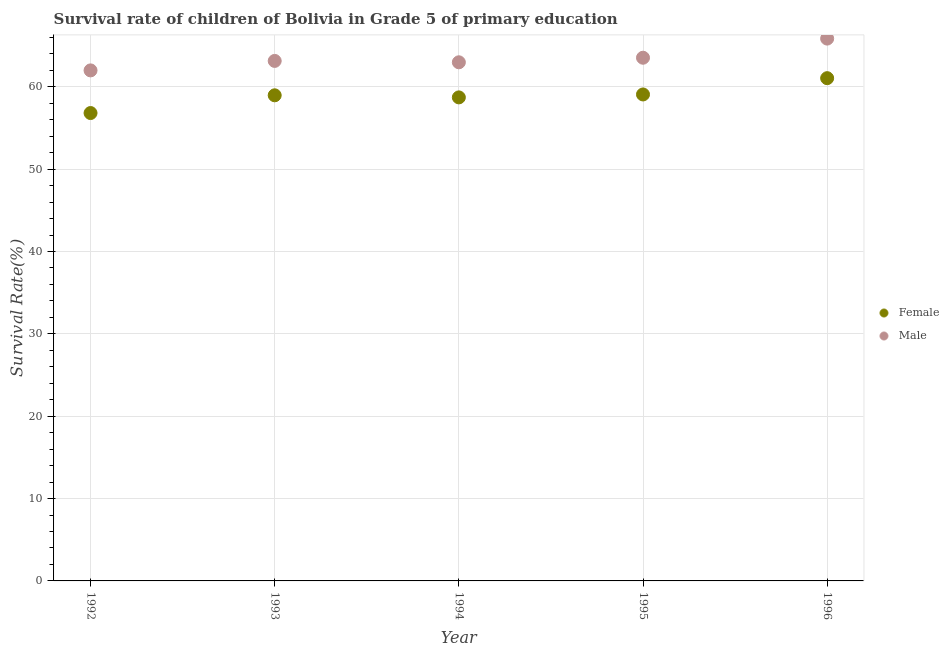Is the number of dotlines equal to the number of legend labels?
Your response must be concise. Yes. What is the survival rate of male students in primary education in 1994?
Offer a terse response. 62.98. Across all years, what is the maximum survival rate of male students in primary education?
Provide a succinct answer. 65.85. Across all years, what is the minimum survival rate of male students in primary education?
Your answer should be very brief. 61.99. In which year was the survival rate of female students in primary education minimum?
Provide a succinct answer. 1992. What is the total survival rate of female students in primary education in the graph?
Ensure brevity in your answer.  294.62. What is the difference between the survival rate of male students in primary education in 1992 and that in 1995?
Provide a short and direct response. -1.54. What is the difference between the survival rate of female students in primary education in 1994 and the survival rate of male students in primary education in 1993?
Your answer should be compact. -4.43. What is the average survival rate of female students in primary education per year?
Make the answer very short. 58.92. In the year 1994, what is the difference between the survival rate of male students in primary education and survival rate of female students in primary education?
Ensure brevity in your answer.  4.26. What is the ratio of the survival rate of female students in primary education in 1995 to that in 1996?
Make the answer very short. 0.97. Is the difference between the survival rate of male students in primary education in 1995 and 1996 greater than the difference between the survival rate of female students in primary education in 1995 and 1996?
Your response must be concise. No. What is the difference between the highest and the second highest survival rate of female students in primary education?
Provide a succinct answer. 1.98. What is the difference between the highest and the lowest survival rate of female students in primary education?
Offer a terse response. 4.23. In how many years, is the survival rate of male students in primary education greater than the average survival rate of male students in primary education taken over all years?
Ensure brevity in your answer.  2. Is the sum of the survival rate of female students in primary education in 1992 and 1993 greater than the maximum survival rate of male students in primary education across all years?
Keep it short and to the point. Yes. Does the survival rate of female students in primary education monotonically increase over the years?
Offer a terse response. No. Is the survival rate of male students in primary education strictly greater than the survival rate of female students in primary education over the years?
Provide a succinct answer. Yes. How many dotlines are there?
Make the answer very short. 2. How many years are there in the graph?
Your answer should be very brief. 5. What is the difference between two consecutive major ticks on the Y-axis?
Your answer should be very brief. 10. Does the graph contain any zero values?
Provide a short and direct response. No. Where does the legend appear in the graph?
Offer a very short reply. Center right. What is the title of the graph?
Give a very brief answer. Survival rate of children of Bolivia in Grade 5 of primary education. What is the label or title of the Y-axis?
Your response must be concise. Survival Rate(%). What is the Survival Rate(%) in Female in 1992?
Give a very brief answer. 56.81. What is the Survival Rate(%) of Male in 1992?
Provide a succinct answer. 61.99. What is the Survival Rate(%) of Female in 1993?
Provide a short and direct response. 58.97. What is the Survival Rate(%) in Male in 1993?
Offer a terse response. 63.14. What is the Survival Rate(%) of Female in 1994?
Offer a very short reply. 58.72. What is the Survival Rate(%) in Male in 1994?
Your answer should be compact. 62.98. What is the Survival Rate(%) in Female in 1995?
Offer a very short reply. 59.07. What is the Survival Rate(%) of Male in 1995?
Your answer should be very brief. 63.53. What is the Survival Rate(%) in Female in 1996?
Offer a terse response. 61.05. What is the Survival Rate(%) in Male in 1996?
Offer a terse response. 65.85. Across all years, what is the maximum Survival Rate(%) in Female?
Offer a terse response. 61.05. Across all years, what is the maximum Survival Rate(%) of Male?
Provide a succinct answer. 65.85. Across all years, what is the minimum Survival Rate(%) in Female?
Offer a terse response. 56.81. Across all years, what is the minimum Survival Rate(%) of Male?
Your answer should be compact. 61.99. What is the total Survival Rate(%) in Female in the graph?
Provide a succinct answer. 294.62. What is the total Survival Rate(%) of Male in the graph?
Ensure brevity in your answer.  317.5. What is the difference between the Survival Rate(%) in Female in 1992 and that in 1993?
Your response must be concise. -2.15. What is the difference between the Survival Rate(%) in Male in 1992 and that in 1993?
Offer a very short reply. -1.15. What is the difference between the Survival Rate(%) in Female in 1992 and that in 1994?
Give a very brief answer. -1.9. What is the difference between the Survival Rate(%) in Male in 1992 and that in 1994?
Your answer should be compact. -0.98. What is the difference between the Survival Rate(%) of Female in 1992 and that in 1995?
Your answer should be very brief. -2.26. What is the difference between the Survival Rate(%) of Male in 1992 and that in 1995?
Your response must be concise. -1.54. What is the difference between the Survival Rate(%) in Female in 1992 and that in 1996?
Offer a terse response. -4.23. What is the difference between the Survival Rate(%) in Male in 1992 and that in 1996?
Provide a succinct answer. -3.86. What is the difference between the Survival Rate(%) in Female in 1993 and that in 1994?
Provide a short and direct response. 0.25. What is the difference between the Survival Rate(%) of Male in 1993 and that in 1994?
Provide a short and direct response. 0.17. What is the difference between the Survival Rate(%) of Female in 1993 and that in 1995?
Offer a terse response. -0.1. What is the difference between the Survival Rate(%) in Male in 1993 and that in 1995?
Your answer should be very brief. -0.39. What is the difference between the Survival Rate(%) in Female in 1993 and that in 1996?
Your answer should be compact. -2.08. What is the difference between the Survival Rate(%) of Male in 1993 and that in 1996?
Your response must be concise. -2.71. What is the difference between the Survival Rate(%) of Female in 1994 and that in 1995?
Provide a short and direct response. -0.36. What is the difference between the Survival Rate(%) of Male in 1994 and that in 1995?
Ensure brevity in your answer.  -0.55. What is the difference between the Survival Rate(%) of Female in 1994 and that in 1996?
Keep it short and to the point. -2.33. What is the difference between the Survival Rate(%) of Male in 1994 and that in 1996?
Your response must be concise. -2.88. What is the difference between the Survival Rate(%) in Female in 1995 and that in 1996?
Keep it short and to the point. -1.98. What is the difference between the Survival Rate(%) of Male in 1995 and that in 1996?
Give a very brief answer. -2.32. What is the difference between the Survival Rate(%) of Female in 1992 and the Survival Rate(%) of Male in 1993?
Offer a very short reply. -6.33. What is the difference between the Survival Rate(%) of Female in 1992 and the Survival Rate(%) of Male in 1994?
Ensure brevity in your answer.  -6.16. What is the difference between the Survival Rate(%) of Female in 1992 and the Survival Rate(%) of Male in 1995?
Give a very brief answer. -6.72. What is the difference between the Survival Rate(%) in Female in 1992 and the Survival Rate(%) in Male in 1996?
Make the answer very short. -9.04. What is the difference between the Survival Rate(%) in Female in 1993 and the Survival Rate(%) in Male in 1994?
Provide a succinct answer. -4.01. What is the difference between the Survival Rate(%) of Female in 1993 and the Survival Rate(%) of Male in 1995?
Offer a very short reply. -4.56. What is the difference between the Survival Rate(%) in Female in 1993 and the Survival Rate(%) in Male in 1996?
Your answer should be very brief. -6.89. What is the difference between the Survival Rate(%) of Female in 1994 and the Survival Rate(%) of Male in 1995?
Keep it short and to the point. -4.82. What is the difference between the Survival Rate(%) of Female in 1994 and the Survival Rate(%) of Male in 1996?
Give a very brief answer. -7.14. What is the difference between the Survival Rate(%) of Female in 1995 and the Survival Rate(%) of Male in 1996?
Your response must be concise. -6.78. What is the average Survival Rate(%) of Female per year?
Your answer should be very brief. 58.92. What is the average Survival Rate(%) of Male per year?
Offer a terse response. 63.5. In the year 1992, what is the difference between the Survival Rate(%) of Female and Survival Rate(%) of Male?
Your answer should be compact. -5.18. In the year 1993, what is the difference between the Survival Rate(%) of Female and Survival Rate(%) of Male?
Your answer should be very brief. -4.18. In the year 1994, what is the difference between the Survival Rate(%) in Female and Survival Rate(%) in Male?
Your answer should be very brief. -4.26. In the year 1995, what is the difference between the Survival Rate(%) in Female and Survival Rate(%) in Male?
Provide a succinct answer. -4.46. In the year 1996, what is the difference between the Survival Rate(%) in Female and Survival Rate(%) in Male?
Give a very brief answer. -4.81. What is the ratio of the Survival Rate(%) of Female in 1992 to that in 1993?
Keep it short and to the point. 0.96. What is the ratio of the Survival Rate(%) of Male in 1992 to that in 1993?
Your response must be concise. 0.98. What is the ratio of the Survival Rate(%) in Female in 1992 to that in 1994?
Your answer should be compact. 0.97. What is the ratio of the Survival Rate(%) of Male in 1992 to that in 1994?
Provide a succinct answer. 0.98. What is the ratio of the Survival Rate(%) in Female in 1992 to that in 1995?
Offer a terse response. 0.96. What is the ratio of the Survival Rate(%) of Male in 1992 to that in 1995?
Your response must be concise. 0.98. What is the ratio of the Survival Rate(%) of Female in 1992 to that in 1996?
Provide a short and direct response. 0.93. What is the ratio of the Survival Rate(%) in Male in 1992 to that in 1996?
Provide a short and direct response. 0.94. What is the ratio of the Survival Rate(%) of Male in 1993 to that in 1994?
Offer a very short reply. 1. What is the ratio of the Survival Rate(%) of Male in 1993 to that in 1995?
Provide a short and direct response. 0.99. What is the ratio of the Survival Rate(%) in Female in 1993 to that in 1996?
Provide a short and direct response. 0.97. What is the ratio of the Survival Rate(%) in Male in 1993 to that in 1996?
Offer a very short reply. 0.96. What is the ratio of the Survival Rate(%) of Female in 1994 to that in 1995?
Ensure brevity in your answer.  0.99. What is the ratio of the Survival Rate(%) in Female in 1994 to that in 1996?
Keep it short and to the point. 0.96. What is the ratio of the Survival Rate(%) in Male in 1994 to that in 1996?
Your answer should be very brief. 0.96. What is the ratio of the Survival Rate(%) of Female in 1995 to that in 1996?
Offer a terse response. 0.97. What is the ratio of the Survival Rate(%) of Male in 1995 to that in 1996?
Give a very brief answer. 0.96. What is the difference between the highest and the second highest Survival Rate(%) in Female?
Provide a short and direct response. 1.98. What is the difference between the highest and the second highest Survival Rate(%) of Male?
Your answer should be compact. 2.32. What is the difference between the highest and the lowest Survival Rate(%) of Female?
Give a very brief answer. 4.23. What is the difference between the highest and the lowest Survival Rate(%) in Male?
Make the answer very short. 3.86. 